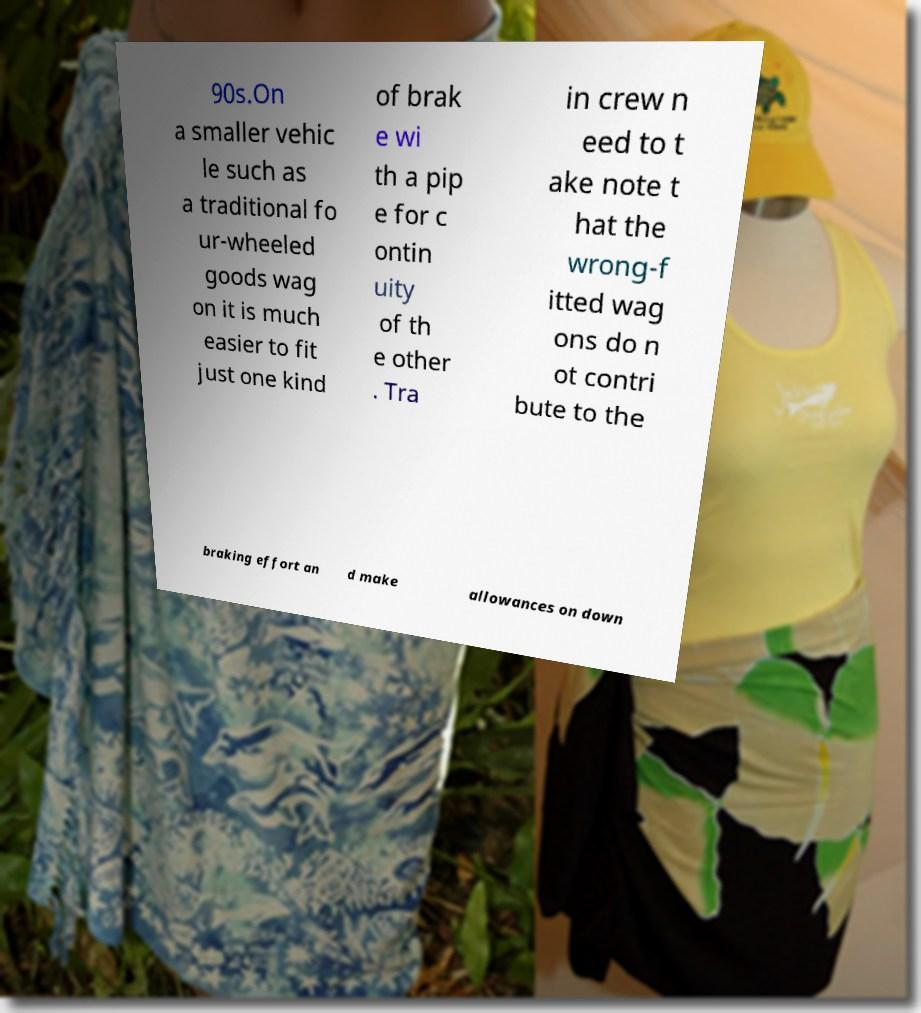Can you accurately transcribe the text from the provided image for me? 90s.On a smaller vehic le such as a traditional fo ur-wheeled goods wag on it is much easier to fit just one kind of brak e wi th a pip e for c ontin uity of th e other . Tra in crew n eed to t ake note t hat the wrong-f itted wag ons do n ot contri bute to the braking effort an d make allowances on down 